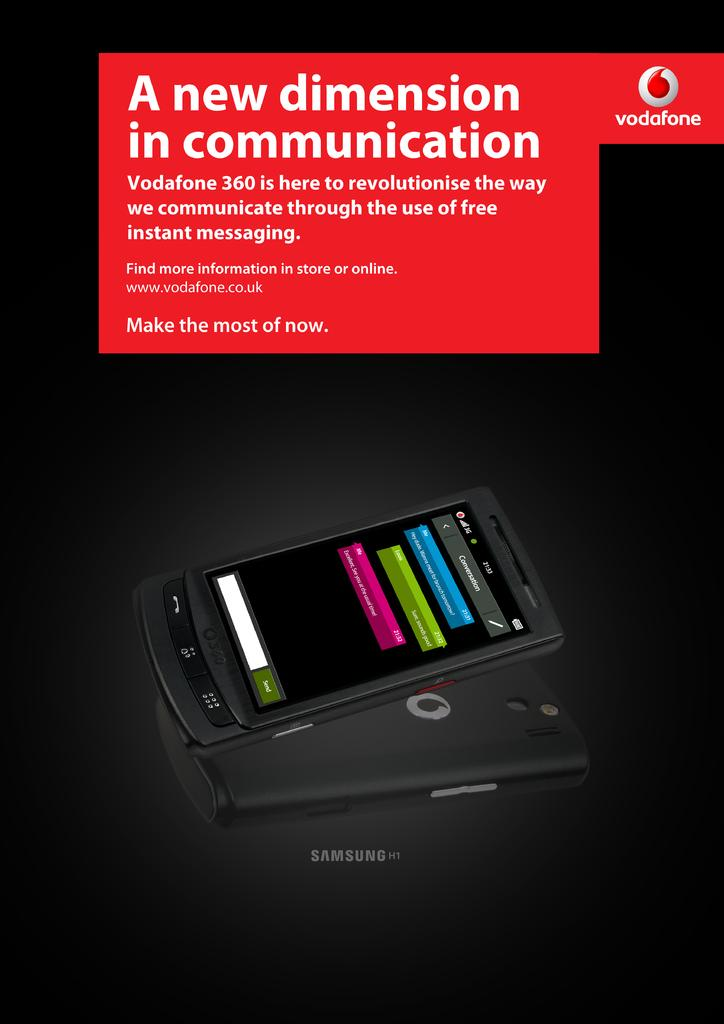Provide a one-sentence caption for the provided image. a samsung phone that talks of it's features having a new dimension of communication. 